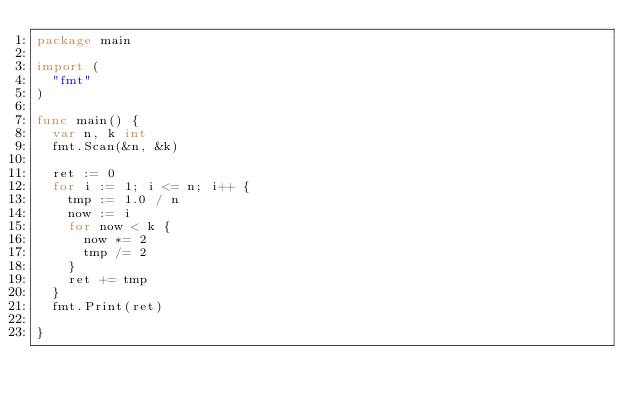Convert code to text. <code><loc_0><loc_0><loc_500><loc_500><_Go_>package main

import (
	"fmt"
)

func main() {
	var n, k int
	fmt.Scan(&n, &k)

	ret := 0
	for i := 1; i <= n; i++ {
		tmp := 1.0 / n
		now := i
		for now < k {
			now *= 2
			tmp /= 2
		}
		ret += tmp
	}
	fmt.Print(ret)

}
</code> 